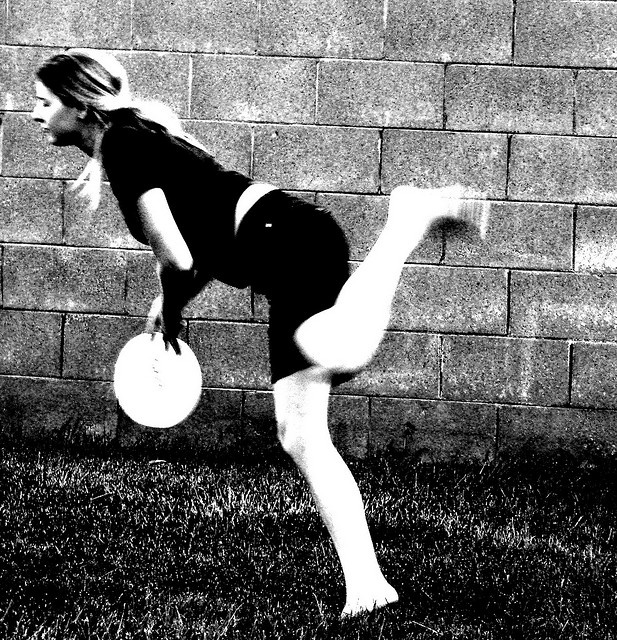Describe the objects in this image and their specific colors. I can see people in gray, black, white, and darkgray tones and frisbee in gray, white, black, and darkgray tones in this image. 